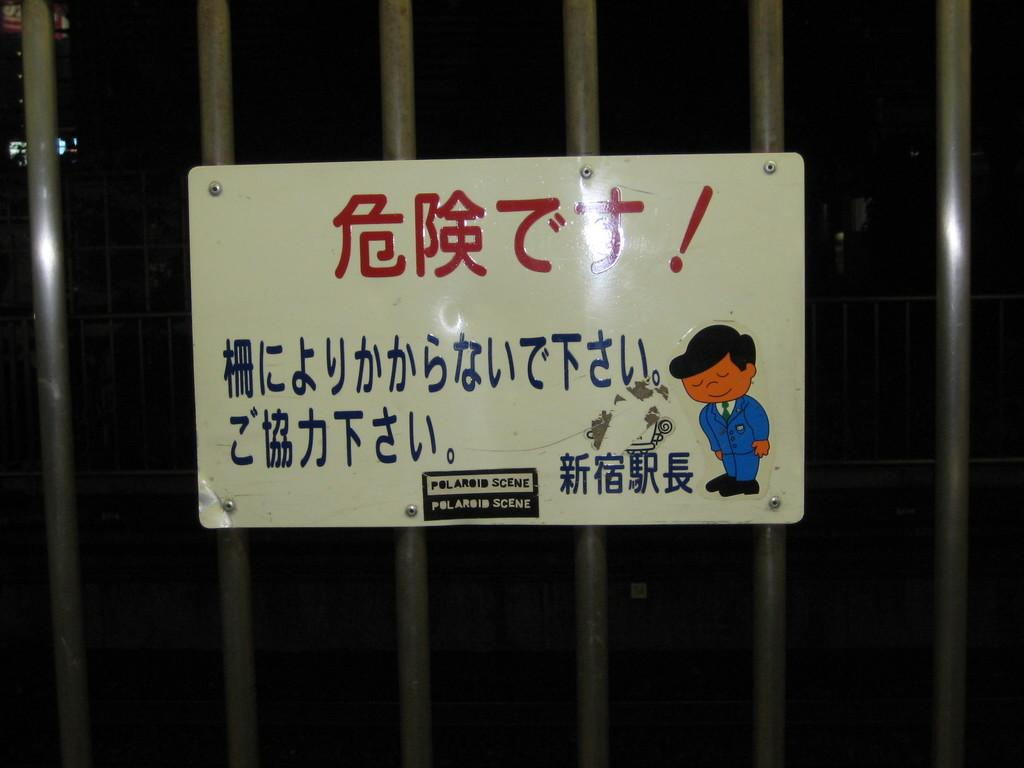What objects can be seen in the image? There are poles in the image. What is attached to the poles? There is a sign board on the poles. Can you see a band playing music on the poles in the image? No, there is no band playing music on the poles in the image. 